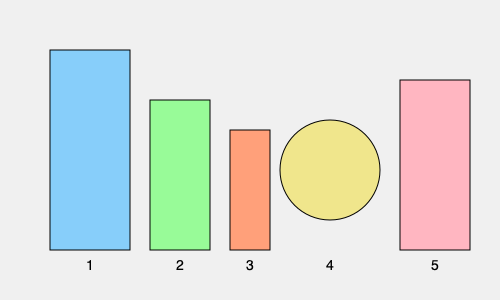Based on the shapes and sizes of the skincare product containers shown above, what is the correct order of application for a daytime skincare routine? To determine the correct order of applying skincare products, we need to consider the general rule of applying products from thinnest to thickest consistency, with sunscreen always being the last step in a daytime routine. Let's analyze each product:

1. The tallest and widest bottle (1) is likely a cleanser, which is always the first step in any skincare routine.
2. The second tallest bottle (2) is probably a toner, which is typically applied after cleansing.
3. The smallest bottle (3) is likely a serum, which is usually thin and applied before heavier products.
4. The round container (4) is probably a moisturizer, which is generally thicker than serums but thinner than sunscreen.
5. The last bottle (5) is likely sunscreen, which should always be the final step in a daytime skincare routine.

Therefore, the correct order of application would be:
1 (Cleanser) → 2 (Toner) → 3 (Serum) → 4 (Moisturizer) → 5 (Sunscreen)
Answer: 1-2-3-4-5 